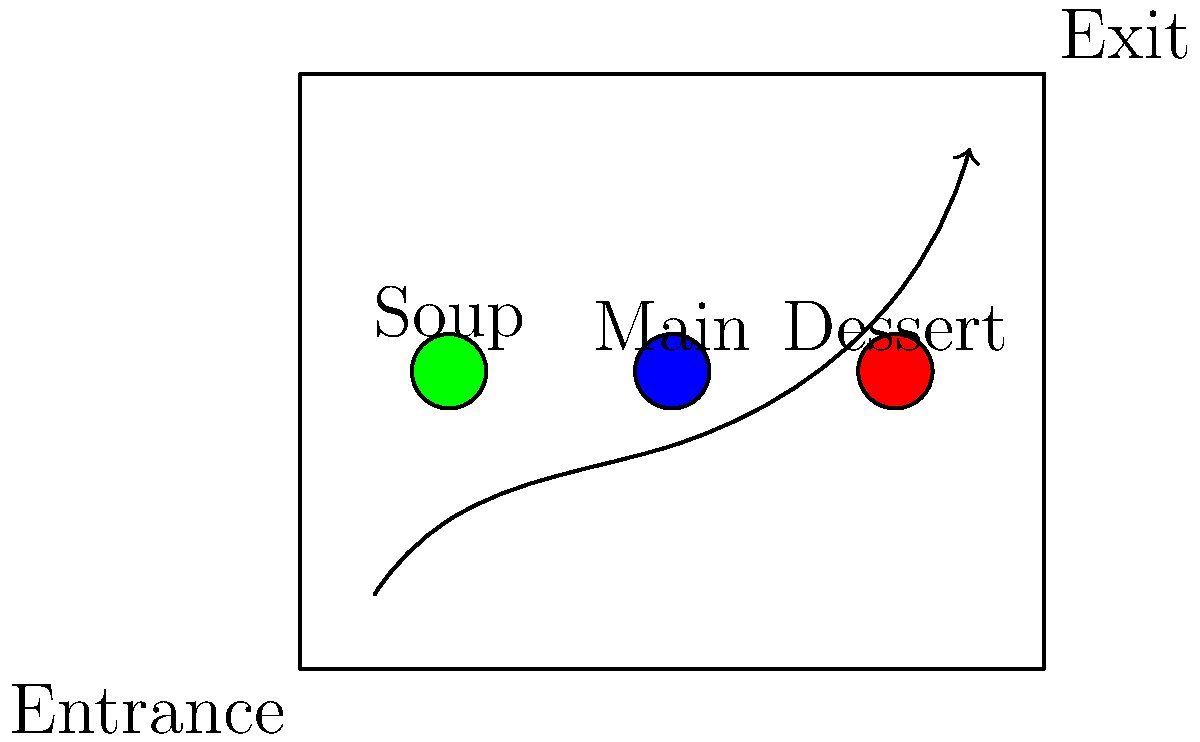Based on the layout of the soup kitchen serving area shown above, which arrangement of serving stations (soup, main course, dessert) would be most efficient for the flow of people through the line? To determine the most efficient layout for the food serving line, we need to consider the following factors:

1. Traffic flow: The arrow indicates the direction of movement from the entrance to the exit.
2. Station placement: The three serving stations are represented by colored circles (green, blue, and red).
3. Logical order: Typically, meals are served in the order of soup, main course, and then dessert.

Analyzing the layout:

1. The green station is closest to the entrance and the beginning of the queue line.
2. The blue station is in the middle of the room and the queue line.
3. The red station is closest to the exit and the end of the queue line.

For the most efficient flow:

1. Soup should be served first (green station) as it's typically the start of a meal and closest to the entrance.
2. The main course should be served second (blue station) as it's the core of the meal and in the middle of the line.
3. Dessert should be served last (red station) as it's the final part of the meal and closest to the exit.

This arrangement minimizes backtracking and ensures a smooth, logical progression through the serving line.
Answer: Soup (green), Main (blue), Dessert (red) 